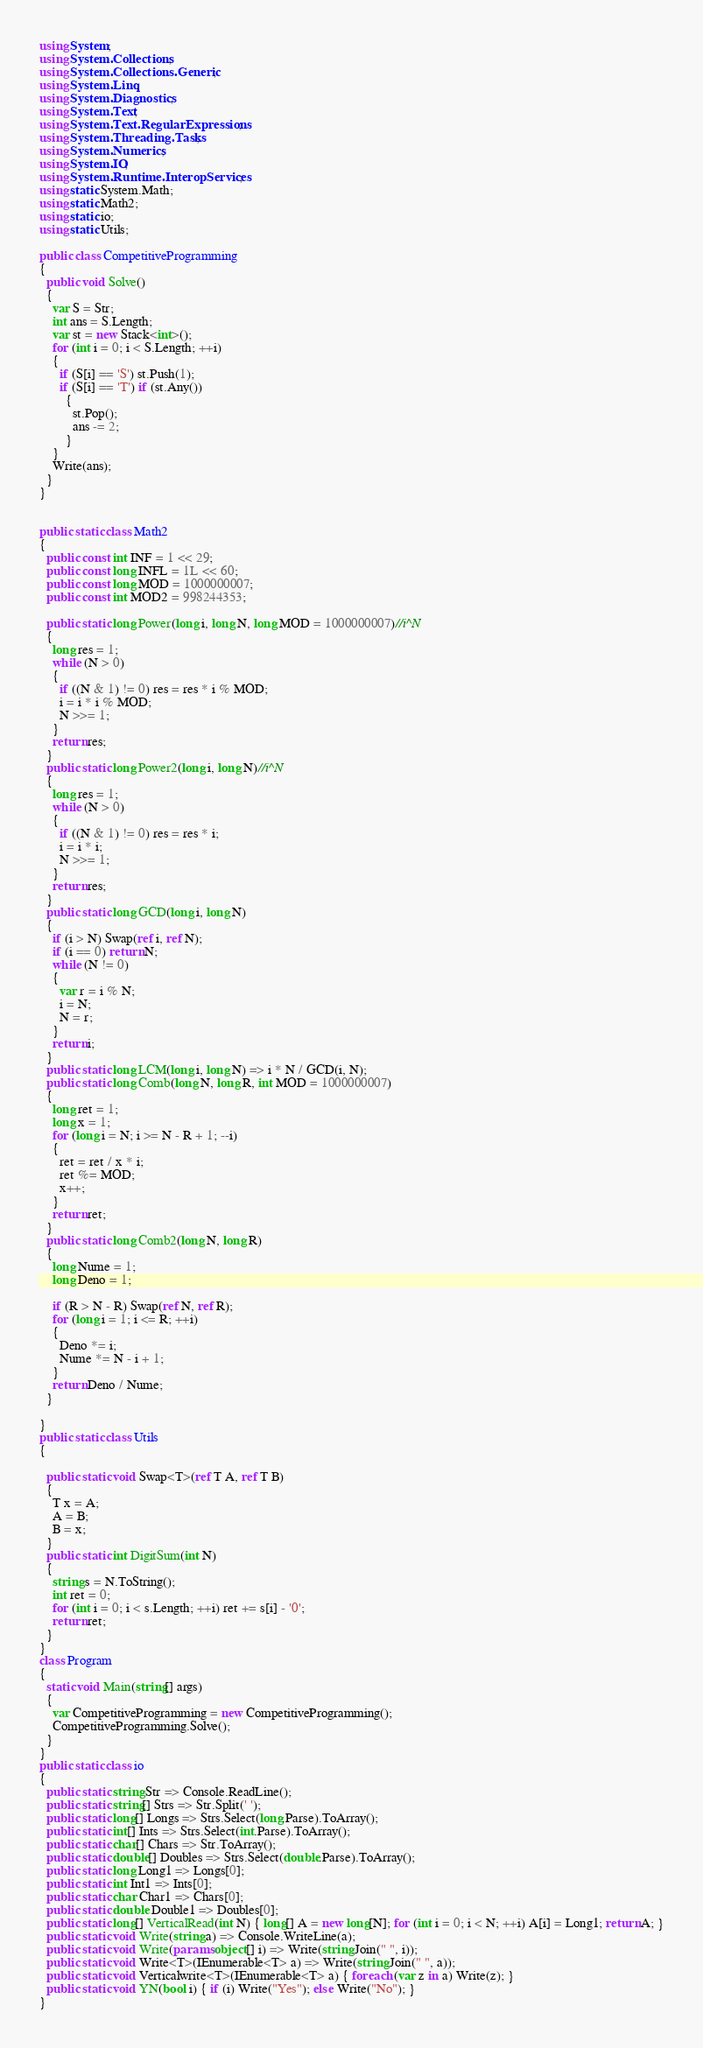<code> <loc_0><loc_0><loc_500><loc_500><_C#_>using System;
using System.Collections;
using System.Collections.Generic;
using System.Linq;
using System.Diagnostics;
using System.Text;
using System.Text.RegularExpressions;
using System.Threading.Tasks;
using System.Numerics;
using System.IO;
using System.Runtime.InteropServices;
using static System.Math;
using static Math2;
using static io;
using static Utils;

public class CompetitiveProgramming
{
  public void Solve()
  {
    var S = Str;
    int ans = S.Length;
    var st = new Stack<int>();
    for (int i = 0; i < S.Length; ++i)
    {
      if (S[i] == 'S') st.Push(1);
      if (S[i] == 'T') if (st.Any())
        {
          st.Pop();
          ans -= 2;
        }
    }
    Write(ans);
  }
}


public static class Math2
{
  public const int INF = 1 << 29;
  public const long INFL = 1L << 60;
  public const long MOD = 1000000007;
  public const int MOD2 = 998244353;

  public static long Power(long i, long N, long MOD = 1000000007)//i^N
  {
    long res = 1;
    while (N > 0)
    {
      if ((N & 1) != 0) res = res * i % MOD;
      i = i * i % MOD;
      N >>= 1;
    }
    return res;
  }
  public static long Power2(long i, long N)//i^N
  {
    long res = 1;
    while (N > 0)
    {
      if ((N & 1) != 0) res = res * i;
      i = i * i;
      N >>= 1;
    }
    return res;
  }
  public static long GCD(long i, long N)
  {
    if (i > N) Swap(ref i, ref N);
    if (i == 0) return N;
    while (N != 0)
    {
      var r = i % N;
      i = N;
      N = r;
    }
    return i;
  }
  public static long LCM(long i, long N) => i * N / GCD(i, N);
  public static long Comb(long N, long R, int MOD = 1000000007)
  {
    long ret = 1;
    long x = 1;
    for (long i = N; i >= N - R + 1; --i)
    {
      ret = ret / x * i;
      ret %= MOD;
      x++;
    }
    return ret;
  }
  public static long Comb2(long N, long R)
  {
    long Nume = 1;
    long Deno = 1;

    if (R > N - R) Swap(ref N, ref R);
    for (long i = 1; i <= R; ++i)
    {
      Deno *= i;
      Nume *= N - i + 1;
    }
    return Deno / Nume;
  }

}
public static class Utils
{

  public static void Swap<T>(ref T A, ref T B)
  {
    T x = A;
    A = B;
    B = x;
  }
  public static int DigitSum(int N)
  {
    string s = N.ToString();
    int ret = 0;
    for (int i = 0; i < s.Length; ++i) ret += s[i] - '0';
    return ret;
  }
}
class Program
{
  static void Main(string[] args)
  {
    var CompetitiveProgramming = new CompetitiveProgramming();
    CompetitiveProgramming.Solve();
  }
}
public static class io
{
  public static string Str => Console.ReadLine();
  public static string[] Strs => Str.Split(' ');
  public static long[] Longs => Strs.Select(long.Parse).ToArray();
  public static int[] Ints => Strs.Select(int.Parse).ToArray();
  public static char[] Chars => Str.ToArray();
  public static double[] Doubles => Strs.Select(double.Parse).ToArray();
  public static long Long1 => Longs[0];
  public static int Int1 => Ints[0];
  public static char Char1 => Chars[0];
  public static double Double1 => Doubles[0];
  public static long[] VerticalRead(int N) { long[] A = new long[N]; for (int i = 0; i < N; ++i) A[i] = Long1; return A; }
  public static void Write(string a) => Console.WriteLine(a);
  public static void Write(params object[] i) => Write(string.Join(" ", i));
  public static void Write<T>(IEnumerable<T> a) => Write(string.Join(" ", a));
  public static void Verticalwrite<T>(IEnumerable<T> a) { foreach (var z in a) Write(z); }
  public static void YN(bool i) { if (i) Write("Yes"); else Write("No"); }
}
</code> 